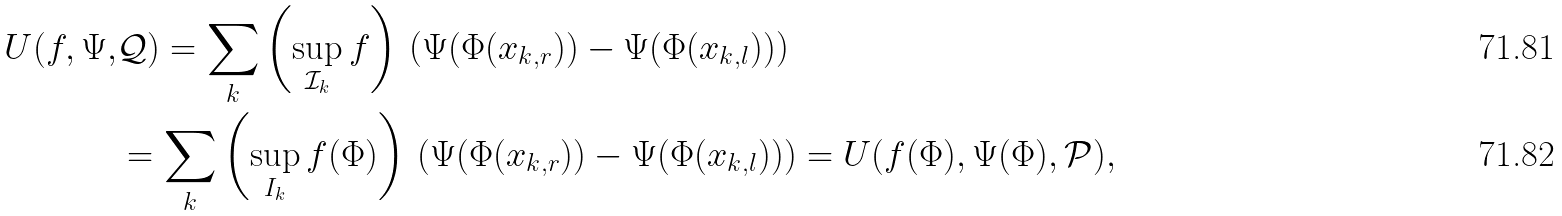Convert formula to latex. <formula><loc_0><loc_0><loc_500><loc_500>U ( f , \Psi , & \mathcal { Q } ) = \sum _ { k } \left ( \sup _ { { \mathcal { I } } _ { k } } f \right ) \, \left ( \Psi ( \Phi ( x _ { k , r } ) ) - \Psi ( \Phi ( x _ { k , l } ) ) \right ) \\ & = \sum _ { k } \left ( \sup _ { I _ { k } } f ( \Phi ) \right ) \, \left ( \Psi ( \Phi ( x _ { k , r } ) ) - \Psi ( \Phi ( x _ { k , l } ) ) \right ) = U ( f ( \Phi ) , \Psi ( \Phi ) , \mathcal { P } ) ,</formula> 